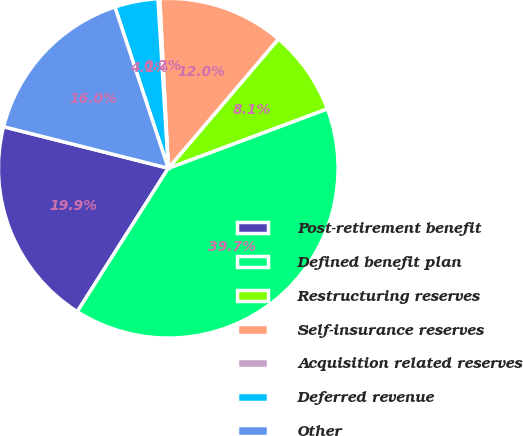Convert chart to OTSL. <chart><loc_0><loc_0><loc_500><loc_500><pie_chart><fcel>Post-retirement benefit<fcel>Defined benefit plan<fcel>Restructuring reserves<fcel>Self-insurance reserves<fcel>Acquisition related reserves<fcel>Deferred revenue<fcel>Other<nl><fcel>19.93%<fcel>39.69%<fcel>8.08%<fcel>12.03%<fcel>0.17%<fcel>4.12%<fcel>15.98%<nl></chart> 